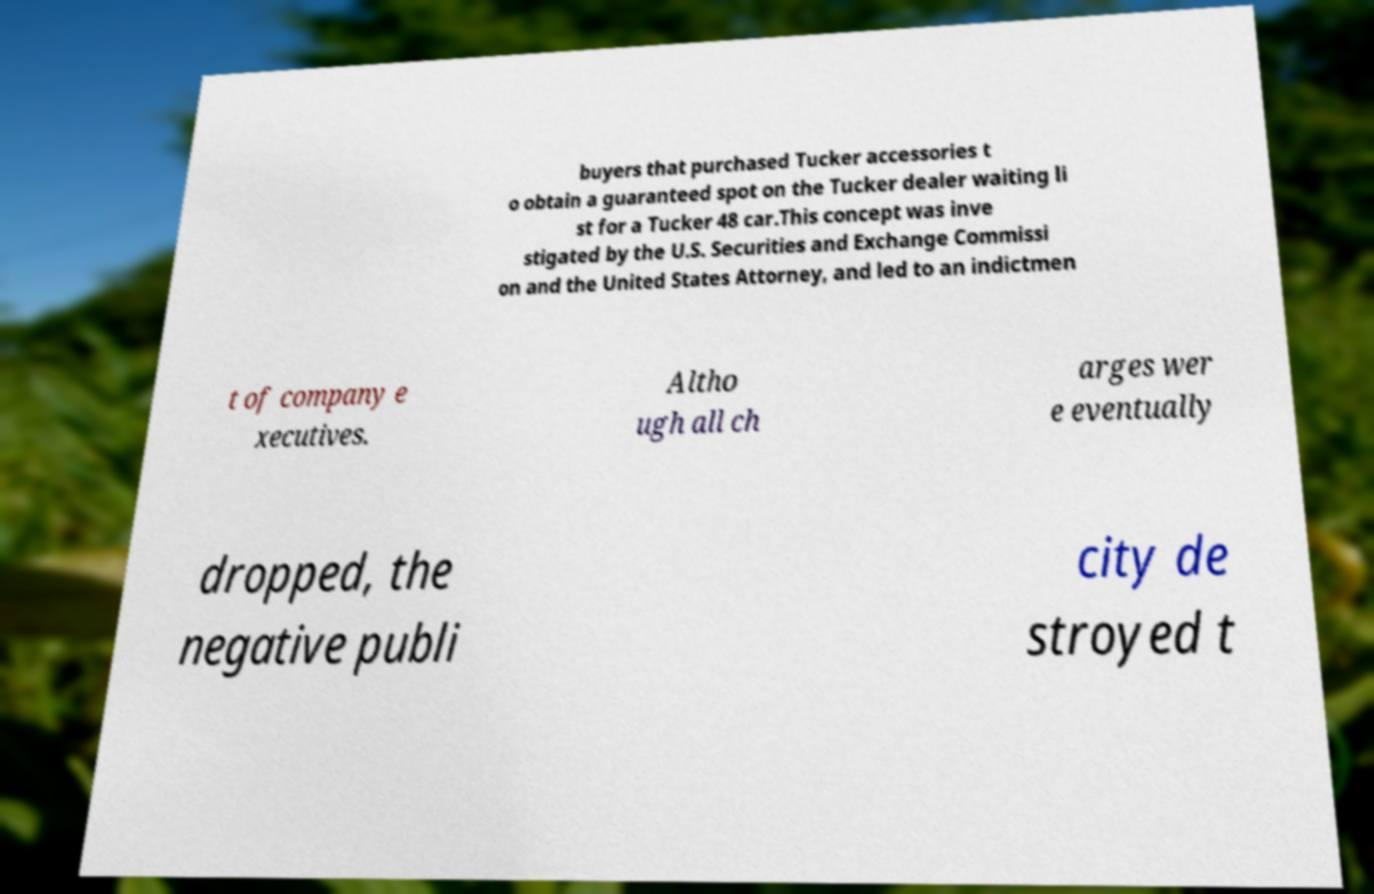There's text embedded in this image that I need extracted. Can you transcribe it verbatim? buyers that purchased Tucker accessories t o obtain a guaranteed spot on the Tucker dealer waiting li st for a Tucker 48 car.This concept was inve stigated by the U.S. Securities and Exchange Commissi on and the United States Attorney, and led to an indictmen t of company e xecutives. Altho ugh all ch arges wer e eventually dropped, the negative publi city de stroyed t 